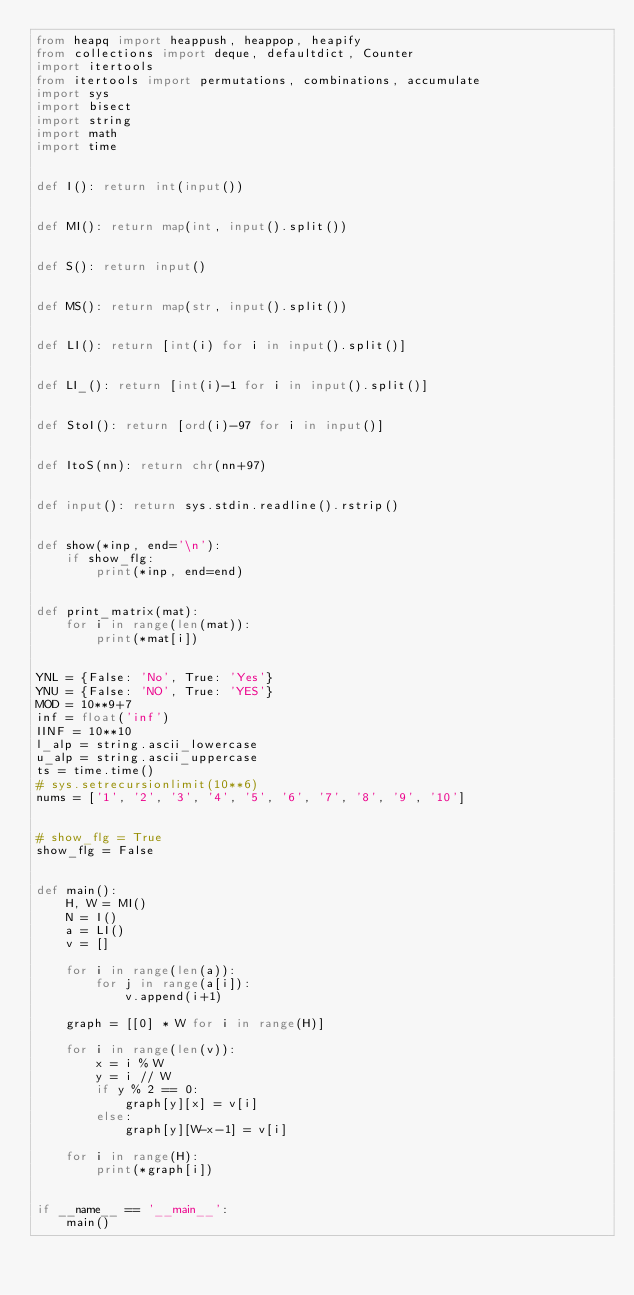<code> <loc_0><loc_0><loc_500><loc_500><_Python_>from heapq import heappush, heappop, heapify
from collections import deque, defaultdict, Counter
import itertools
from itertools import permutations, combinations, accumulate
import sys
import bisect
import string
import math
import time


def I(): return int(input())


def MI(): return map(int, input().split())


def S(): return input()


def MS(): return map(str, input().split())


def LI(): return [int(i) for i in input().split()]


def LI_(): return [int(i)-1 for i in input().split()]


def StoI(): return [ord(i)-97 for i in input()]


def ItoS(nn): return chr(nn+97)


def input(): return sys.stdin.readline().rstrip()


def show(*inp, end='\n'):
    if show_flg:
        print(*inp, end=end)


def print_matrix(mat):
    for i in range(len(mat)):
        print(*mat[i])


YNL = {False: 'No', True: 'Yes'}
YNU = {False: 'NO', True: 'YES'}
MOD = 10**9+7
inf = float('inf')
IINF = 10**10
l_alp = string.ascii_lowercase
u_alp = string.ascii_uppercase
ts = time.time()
# sys.setrecursionlimit(10**6)
nums = ['1', '2', '3', '4', '5', '6', '7', '8', '9', '10']


# show_flg = True
show_flg = False


def main():
    H, W = MI()
    N = I()
    a = LI()
    v = []

    for i in range(len(a)):
        for j in range(a[i]):
            v.append(i+1)

    graph = [[0] * W for i in range(H)]

    for i in range(len(v)):
        x = i % W
        y = i // W
        if y % 2 == 0:
            graph[y][x] = v[i]
        else:
            graph[y][W-x-1] = v[i]

    for i in range(H):
        print(*graph[i])


if __name__ == '__main__':
    main()
</code> 